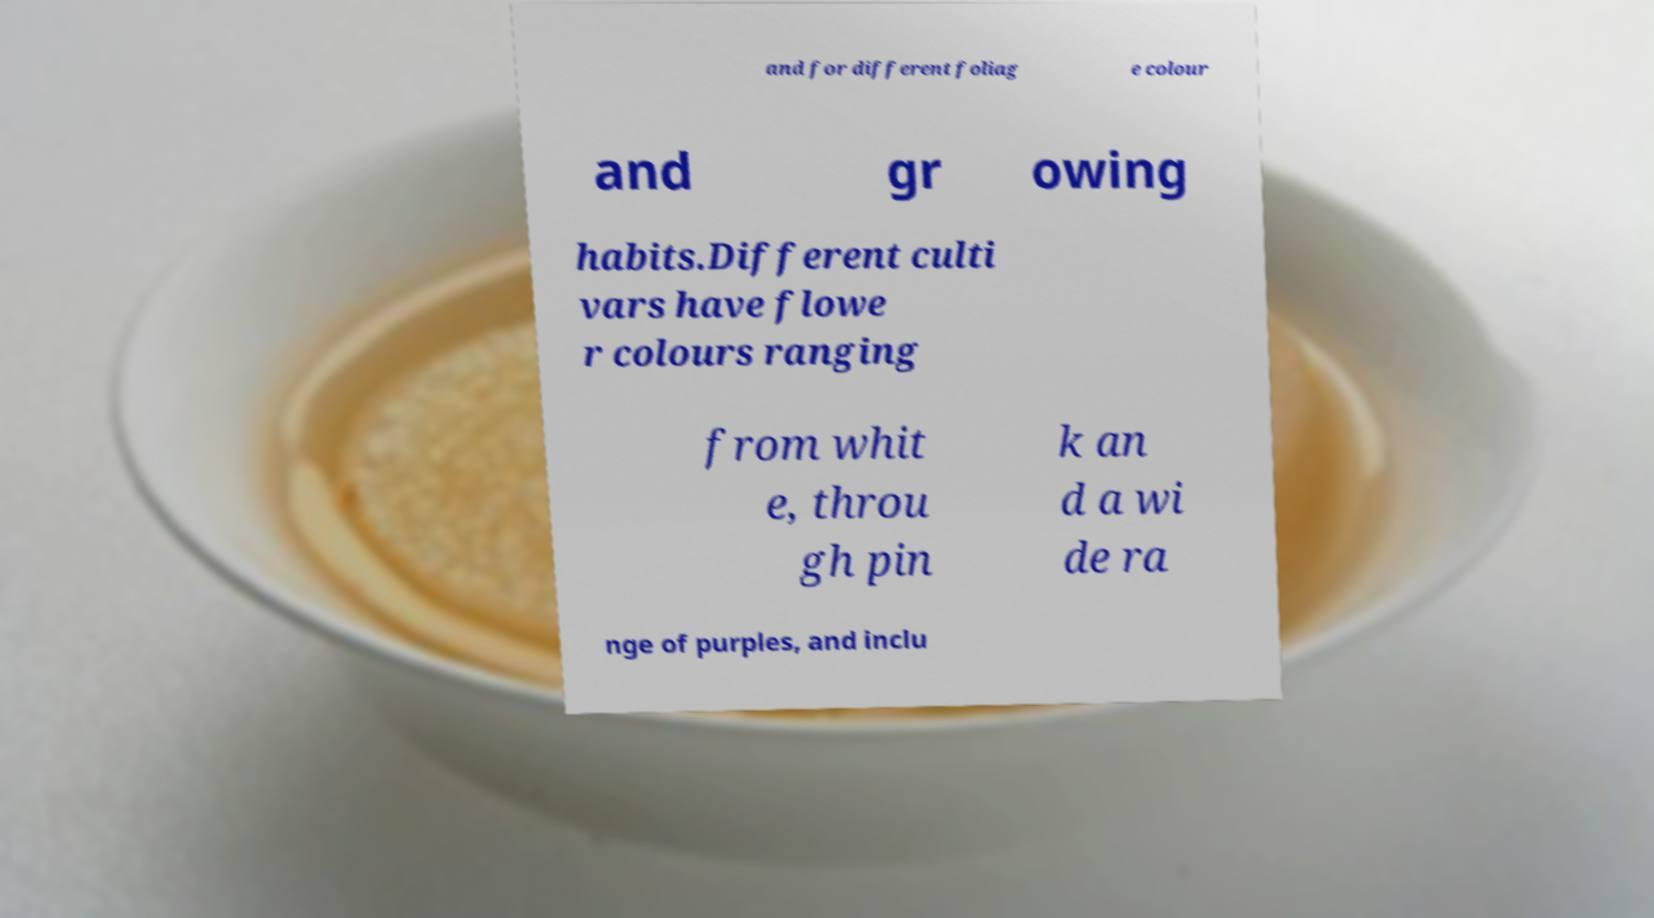Can you read and provide the text displayed in the image?This photo seems to have some interesting text. Can you extract and type it out for me? and for different foliag e colour and gr owing habits.Different culti vars have flowe r colours ranging from whit e, throu gh pin k an d a wi de ra nge of purples, and inclu 